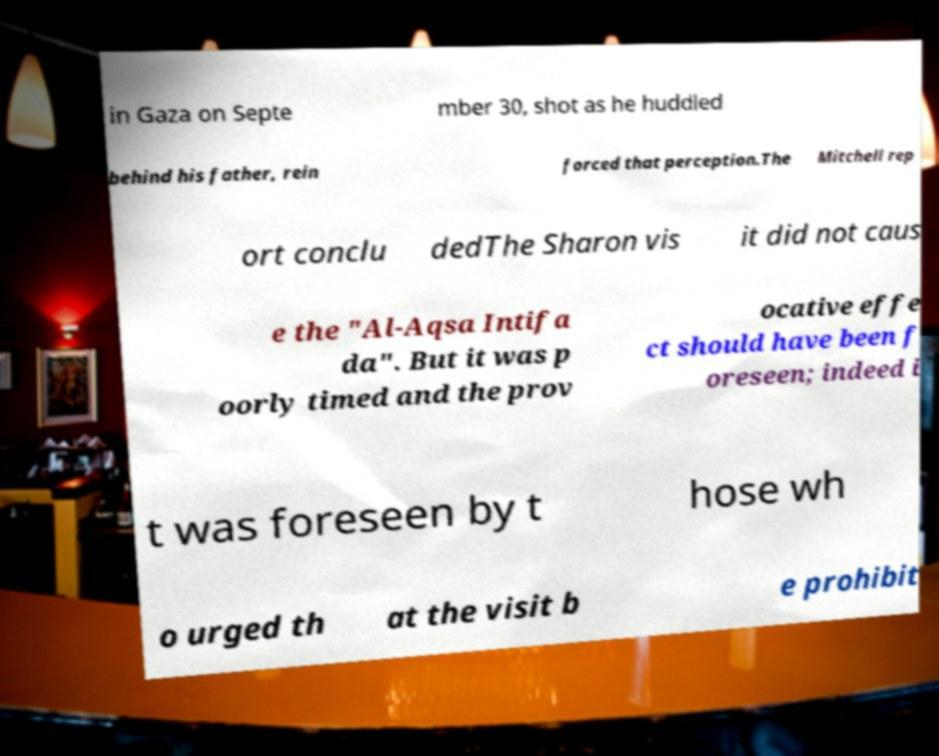Can you read and provide the text displayed in the image?This photo seems to have some interesting text. Can you extract and type it out for me? in Gaza on Septe mber 30, shot as he huddled behind his father, rein forced that perception.The Mitchell rep ort conclu dedThe Sharon vis it did not caus e the "Al-Aqsa Intifa da". But it was p oorly timed and the prov ocative effe ct should have been f oreseen; indeed i t was foreseen by t hose wh o urged th at the visit b e prohibit 